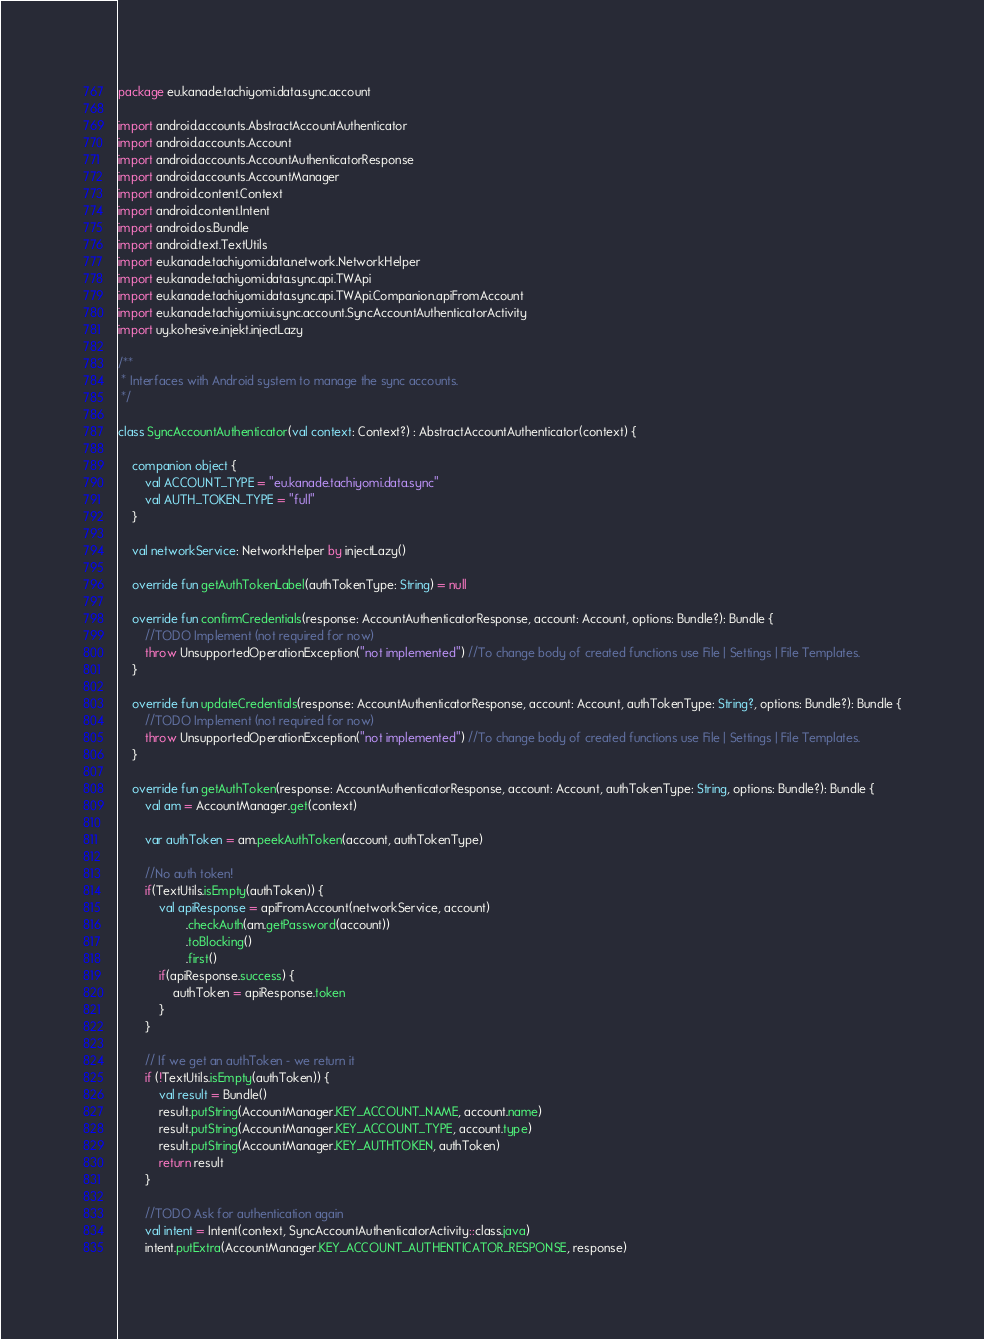<code> <loc_0><loc_0><loc_500><loc_500><_Kotlin_>package eu.kanade.tachiyomi.data.sync.account

import android.accounts.AbstractAccountAuthenticator
import android.accounts.Account
import android.accounts.AccountAuthenticatorResponse
import android.accounts.AccountManager
import android.content.Context
import android.content.Intent
import android.os.Bundle
import android.text.TextUtils
import eu.kanade.tachiyomi.data.network.NetworkHelper
import eu.kanade.tachiyomi.data.sync.api.TWApi
import eu.kanade.tachiyomi.data.sync.api.TWApi.Companion.apiFromAccount
import eu.kanade.tachiyomi.ui.sync.account.SyncAccountAuthenticatorActivity
import uy.kohesive.injekt.injectLazy

/**
 * Interfaces with Android system to manage the sync accounts.
 */

class SyncAccountAuthenticator(val context: Context?) : AbstractAccountAuthenticator(context) {

    companion object {
        val ACCOUNT_TYPE = "eu.kanade.tachiyomi.data.sync"
        val AUTH_TOKEN_TYPE = "full"
    }

    val networkService: NetworkHelper by injectLazy()

    override fun getAuthTokenLabel(authTokenType: String) = null

    override fun confirmCredentials(response: AccountAuthenticatorResponse, account: Account, options: Bundle?): Bundle {
        //TODO Implement (not required for now)
        throw UnsupportedOperationException("not implemented") //To change body of created functions use File | Settings | File Templates.
    }

    override fun updateCredentials(response: AccountAuthenticatorResponse, account: Account, authTokenType: String?, options: Bundle?): Bundle {
        //TODO Implement (not required for now)
        throw UnsupportedOperationException("not implemented") //To change body of created functions use File | Settings | File Templates.
    }

    override fun getAuthToken(response: AccountAuthenticatorResponse, account: Account, authTokenType: String, options: Bundle?): Bundle {
        val am = AccountManager.get(context)

        var authToken = am.peekAuthToken(account, authTokenType)

        //No auth token!
        if(TextUtils.isEmpty(authToken)) {
            val apiResponse = apiFromAccount(networkService, account)
                    .checkAuth(am.getPassword(account))
                    .toBlocking()
                    .first()
            if(apiResponse.success) {
                authToken = apiResponse.token
            }
        }

        // If we get an authToken - we return it
        if (!TextUtils.isEmpty(authToken)) {
            val result = Bundle()
            result.putString(AccountManager.KEY_ACCOUNT_NAME, account.name)
            result.putString(AccountManager.KEY_ACCOUNT_TYPE, account.type)
            result.putString(AccountManager.KEY_AUTHTOKEN, authToken)
            return result
        }

        //TODO Ask for authentication again
        val intent = Intent(context, SyncAccountAuthenticatorActivity::class.java)
        intent.putExtra(AccountManager.KEY_ACCOUNT_AUTHENTICATOR_RESPONSE, response)</code> 